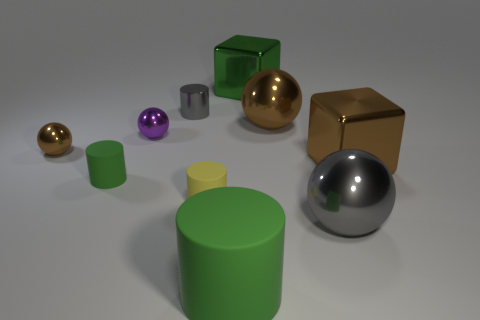Subtract all tiny cylinders. How many cylinders are left? 1 Subtract all blue spheres. How many green cylinders are left? 2 Subtract all gray balls. How many balls are left? 3 Subtract all yellow cylinders. Subtract all yellow blocks. How many cylinders are left? 3 Subtract 0 yellow spheres. How many objects are left? 10 Subtract all balls. How many objects are left? 6 Subtract all large cyan metallic blocks. Subtract all large green cylinders. How many objects are left? 9 Add 2 large brown metallic blocks. How many large brown metallic blocks are left? 3 Add 5 green things. How many green things exist? 8 